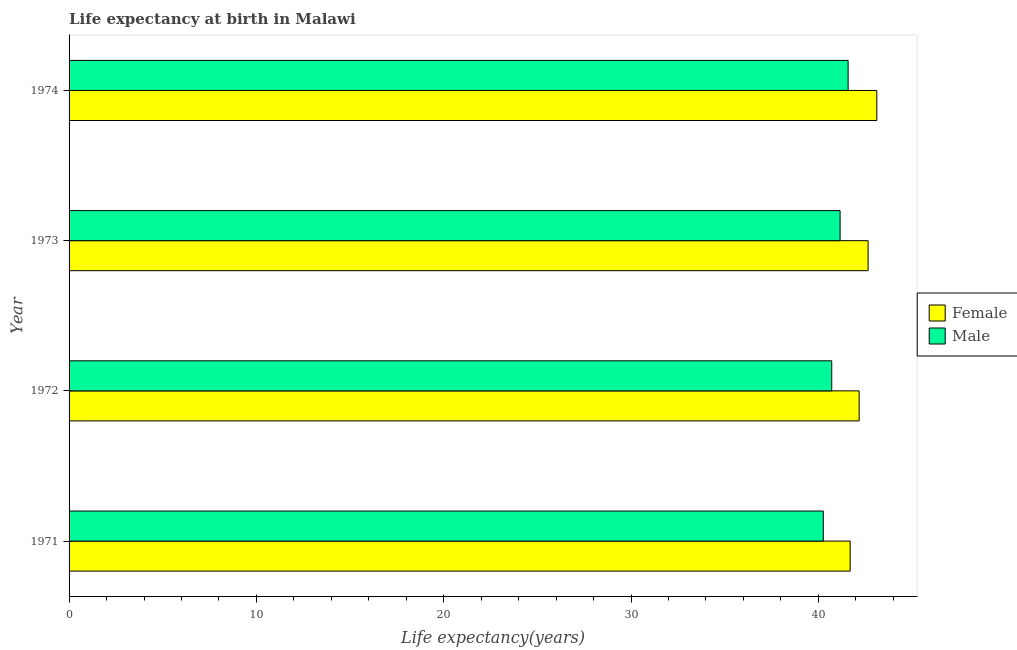How many different coloured bars are there?
Keep it short and to the point. 2. How many groups of bars are there?
Your answer should be compact. 4. Are the number of bars on each tick of the Y-axis equal?
Keep it short and to the point. Yes. How many bars are there on the 3rd tick from the top?
Your answer should be compact. 2. How many bars are there on the 2nd tick from the bottom?
Your answer should be compact. 2. What is the life expectancy(female) in 1973?
Your answer should be compact. 42.66. Across all years, what is the maximum life expectancy(female)?
Provide a succinct answer. 43.12. Across all years, what is the minimum life expectancy(male)?
Offer a terse response. 40.26. In which year was the life expectancy(female) maximum?
Your answer should be very brief. 1974. What is the total life expectancy(male) in the graph?
Provide a short and direct response. 163.73. What is the difference between the life expectancy(male) in 1971 and that in 1974?
Make the answer very short. -1.33. What is the difference between the life expectancy(male) in 1974 and the life expectancy(female) in 1973?
Offer a terse response. -1.07. What is the average life expectancy(male) per year?
Offer a terse response. 40.93. In the year 1973, what is the difference between the life expectancy(female) and life expectancy(male)?
Offer a terse response. 1.5. Is the difference between the life expectancy(female) in 1971 and 1973 greater than the difference between the life expectancy(male) in 1971 and 1973?
Make the answer very short. No. What is the difference between the highest and the second highest life expectancy(female)?
Offer a very short reply. 0.47. What is the difference between the highest and the lowest life expectancy(female)?
Your answer should be compact. 1.42. In how many years, is the life expectancy(male) greater than the average life expectancy(male) taken over all years?
Offer a very short reply. 2. Is the sum of the life expectancy(male) in 1971 and 1974 greater than the maximum life expectancy(female) across all years?
Ensure brevity in your answer.  Yes. What does the 2nd bar from the bottom in 1973 represents?
Your response must be concise. Male. How many bars are there?
Give a very brief answer. 8. What is the difference between two consecutive major ticks on the X-axis?
Your answer should be compact. 10. Does the graph contain grids?
Give a very brief answer. No. Where does the legend appear in the graph?
Ensure brevity in your answer.  Center right. How are the legend labels stacked?
Give a very brief answer. Vertical. What is the title of the graph?
Provide a short and direct response. Life expectancy at birth in Malawi. Does "ODA received" appear as one of the legend labels in the graph?
Provide a succinct answer. No. What is the label or title of the X-axis?
Keep it short and to the point. Life expectancy(years). What is the label or title of the Y-axis?
Offer a terse response. Year. What is the Life expectancy(years) of Female in 1971?
Provide a short and direct response. 41.7. What is the Life expectancy(years) of Male in 1971?
Your answer should be compact. 40.26. What is the Life expectancy(years) of Female in 1972?
Your answer should be compact. 42.18. What is the Life expectancy(years) of Male in 1972?
Your answer should be compact. 40.71. What is the Life expectancy(years) in Female in 1973?
Ensure brevity in your answer.  42.66. What is the Life expectancy(years) of Male in 1973?
Provide a succinct answer. 41.16. What is the Life expectancy(years) in Female in 1974?
Offer a terse response. 43.12. What is the Life expectancy(years) in Male in 1974?
Offer a terse response. 41.59. Across all years, what is the maximum Life expectancy(years) in Female?
Make the answer very short. 43.12. Across all years, what is the maximum Life expectancy(years) in Male?
Provide a succinct answer. 41.59. Across all years, what is the minimum Life expectancy(years) of Female?
Keep it short and to the point. 41.7. Across all years, what is the minimum Life expectancy(years) of Male?
Offer a very short reply. 40.26. What is the total Life expectancy(years) of Female in the graph?
Keep it short and to the point. 169.65. What is the total Life expectancy(years) of Male in the graph?
Your answer should be compact. 163.73. What is the difference between the Life expectancy(years) in Female in 1971 and that in 1972?
Give a very brief answer. -0.48. What is the difference between the Life expectancy(years) of Male in 1971 and that in 1972?
Make the answer very short. -0.45. What is the difference between the Life expectancy(years) in Female in 1971 and that in 1973?
Provide a short and direct response. -0.96. What is the difference between the Life expectancy(years) in Male in 1971 and that in 1973?
Your answer should be compact. -0.9. What is the difference between the Life expectancy(years) of Female in 1971 and that in 1974?
Ensure brevity in your answer.  -1.42. What is the difference between the Life expectancy(years) in Male in 1971 and that in 1974?
Make the answer very short. -1.33. What is the difference between the Life expectancy(years) of Female in 1972 and that in 1973?
Keep it short and to the point. -0.48. What is the difference between the Life expectancy(years) in Male in 1972 and that in 1973?
Your answer should be compact. -0.45. What is the difference between the Life expectancy(years) in Female in 1972 and that in 1974?
Offer a terse response. -0.94. What is the difference between the Life expectancy(years) of Male in 1972 and that in 1974?
Give a very brief answer. -0.88. What is the difference between the Life expectancy(years) of Female in 1973 and that in 1974?
Give a very brief answer. -0.47. What is the difference between the Life expectancy(years) in Male in 1973 and that in 1974?
Keep it short and to the point. -0.43. What is the difference between the Life expectancy(years) in Female in 1971 and the Life expectancy(years) in Male in 1973?
Make the answer very short. 0.54. What is the difference between the Life expectancy(years) in Female in 1971 and the Life expectancy(years) in Male in 1974?
Ensure brevity in your answer.  0.11. What is the difference between the Life expectancy(years) of Female in 1972 and the Life expectancy(years) of Male in 1974?
Your answer should be compact. 0.59. What is the difference between the Life expectancy(years) of Female in 1973 and the Life expectancy(years) of Male in 1974?
Offer a very short reply. 1.07. What is the average Life expectancy(years) of Female per year?
Provide a succinct answer. 42.41. What is the average Life expectancy(years) in Male per year?
Your answer should be compact. 40.93. In the year 1971, what is the difference between the Life expectancy(years) in Female and Life expectancy(years) in Male?
Ensure brevity in your answer.  1.43. In the year 1972, what is the difference between the Life expectancy(years) of Female and Life expectancy(years) of Male?
Make the answer very short. 1.46. In the year 1973, what is the difference between the Life expectancy(years) of Female and Life expectancy(years) of Male?
Make the answer very short. 1.5. In the year 1974, what is the difference between the Life expectancy(years) of Female and Life expectancy(years) of Male?
Keep it short and to the point. 1.53. What is the ratio of the Life expectancy(years) in Male in 1971 to that in 1972?
Your answer should be very brief. 0.99. What is the ratio of the Life expectancy(years) in Female in 1971 to that in 1973?
Offer a terse response. 0.98. What is the ratio of the Life expectancy(years) of Male in 1971 to that in 1973?
Offer a terse response. 0.98. What is the ratio of the Life expectancy(years) in Female in 1971 to that in 1974?
Keep it short and to the point. 0.97. What is the ratio of the Life expectancy(years) in Male in 1971 to that in 1974?
Your answer should be very brief. 0.97. What is the ratio of the Life expectancy(years) in Female in 1972 to that in 1974?
Your answer should be very brief. 0.98. What is the ratio of the Life expectancy(years) in Male in 1972 to that in 1974?
Your answer should be compact. 0.98. What is the ratio of the Life expectancy(years) of Female in 1973 to that in 1974?
Give a very brief answer. 0.99. What is the difference between the highest and the second highest Life expectancy(years) of Female?
Make the answer very short. 0.47. What is the difference between the highest and the second highest Life expectancy(years) in Male?
Give a very brief answer. 0.43. What is the difference between the highest and the lowest Life expectancy(years) in Female?
Provide a succinct answer. 1.42. What is the difference between the highest and the lowest Life expectancy(years) of Male?
Your answer should be very brief. 1.33. 